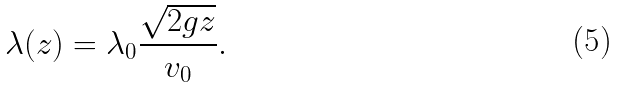<formula> <loc_0><loc_0><loc_500><loc_500>\lambda ( z ) = \lambda _ { 0 } \frac { \sqrt { 2 g z } } { v _ { 0 } } .</formula> 